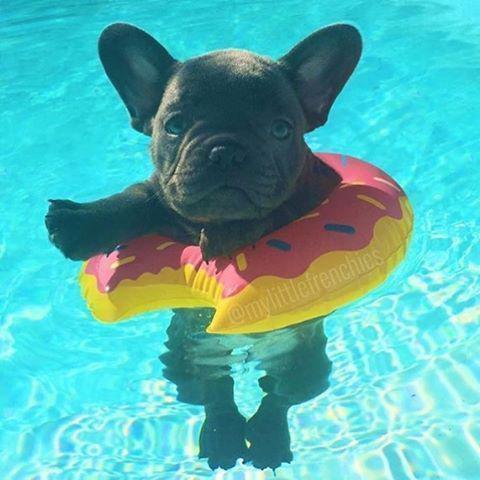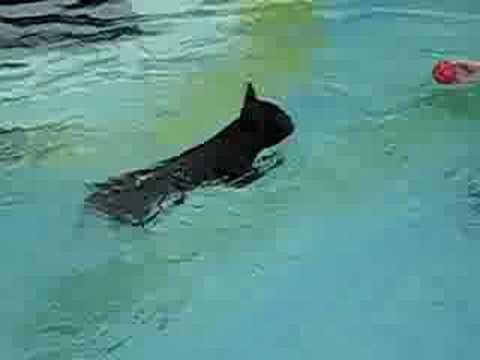The first image is the image on the left, the second image is the image on the right. Analyze the images presented: Is the assertion "Each image contains one dog in a swimming pool, and the right image shows a bulldog swimming at a leftward angle and wearing an orange life vest." valid? Answer yes or no. No. The first image is the image on the left, the second image is the image on the right. Assess this claim about the two images: "One of the images shows a dog floating in a pool while using an inner tube.". Correct or not? Answer yes or no. Yes. 